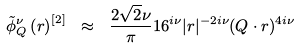Convert formula to latex. <formula><loc_0><loc_0><loc_500><loc_500>\tilde { \phi } ^ { \nu } _ { Q } \left ( r \right ) ^ { [ 2 ] } \ \approx \ \frac { 2 \sqrt { 2 } \nu } { \pi } 1 6 ^ { i \nu } | r | ^ { - 2 i \nu } ( Q \cdot r ) ^ { 4 i \nu }</formula> 